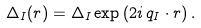Convert formula to latex. <formula><loc_0><loc_0><loc_500><loc_500>\Delta _ { I } ( { r } ) = \Delta _ { I } \exp \left ( 2 i \, { q _ { I } } \cdot { r } \right ) .</formula> 